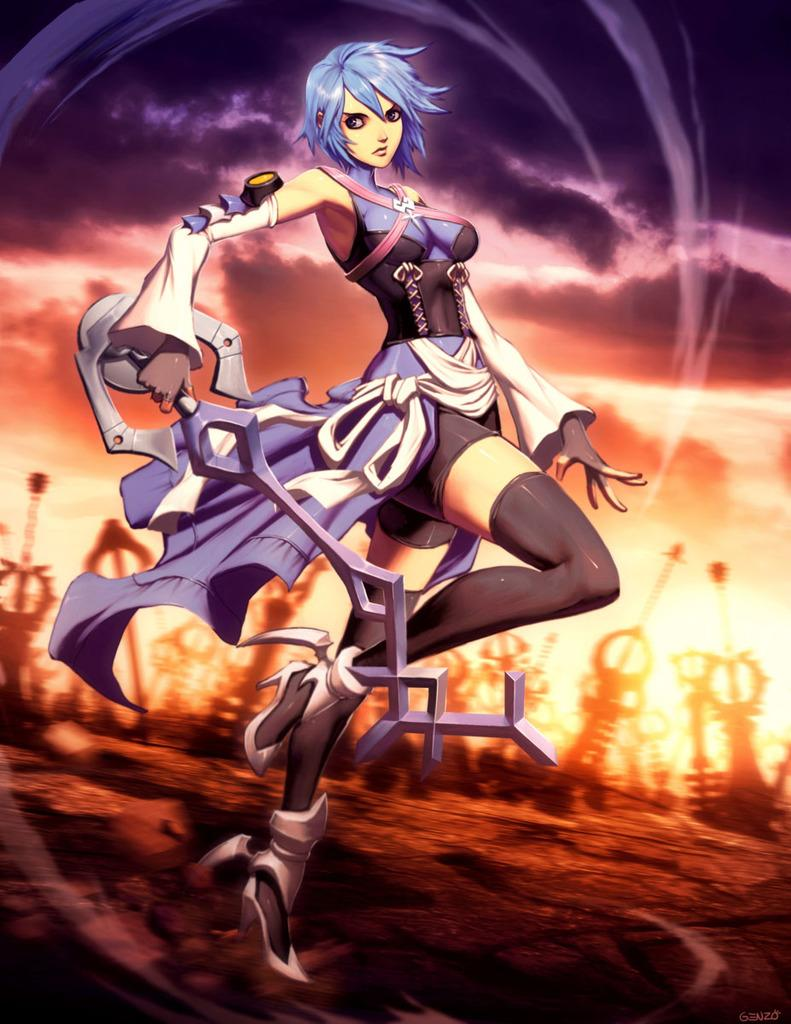What type of picture is the image? The image is an animated picture. What is the person in the foreground doing? The person in the foreground is holding a weapon. What can be seen in the background of the image? There are weapons and persons in the background. What type of honey can be seen dripping from the weapon in the image? There is no honey present in the image; it features a person holding a weapon in the foreground and other elements in the background. 